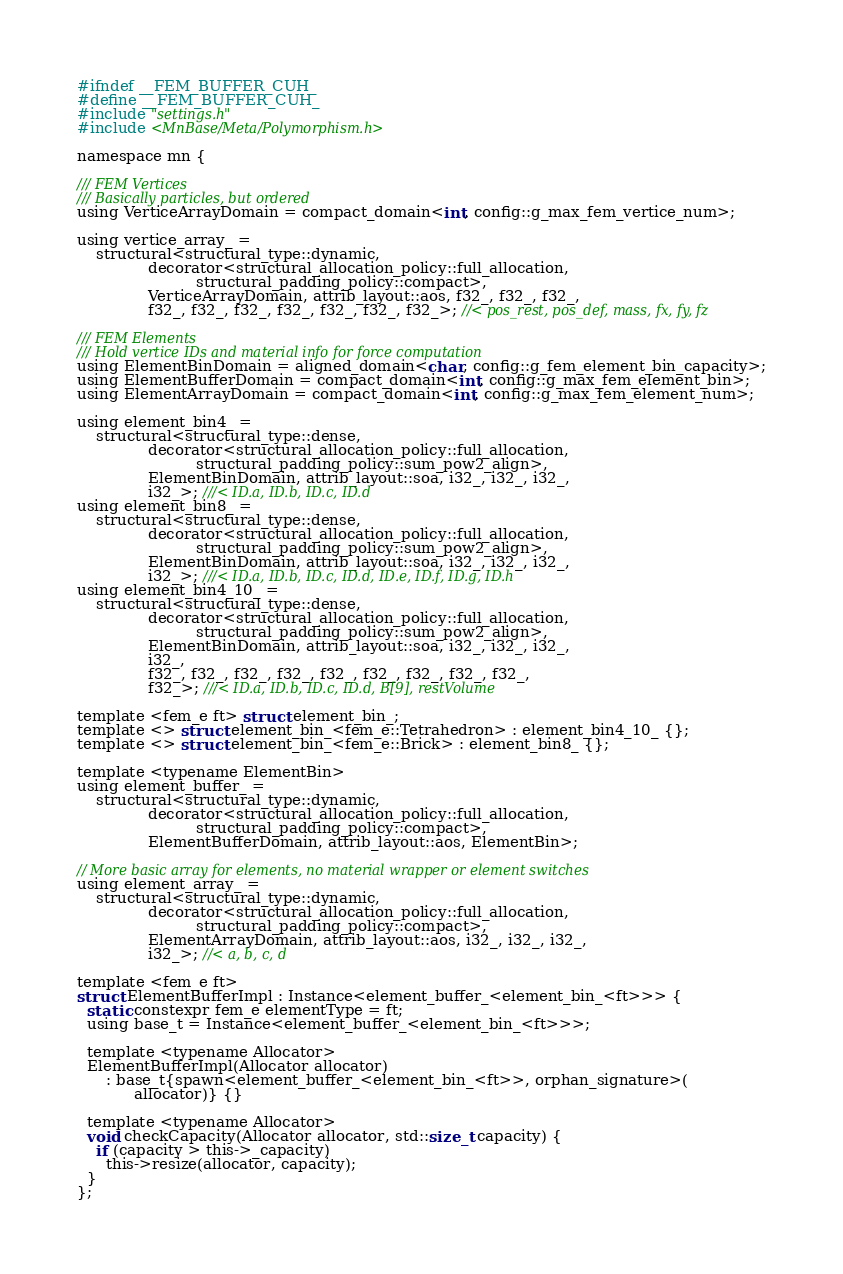<code> <loc_0><loc_0><loc_500><loc_500><_Cuda_>#ifndef __FEM_BUFFER_CUH_
#define __FEM_BUFFER_CUH_
#include "settings.h"
#include <MnBase/Meta/Polymorphism.h>

namespace mn {

/// FEM Vertices
/// Basically particles, but ordered
using VerticeArrayDomain = compact_domain<int, config::g_max_fem_vertice_num>;

using vertice_array_ =
    structural<structural_type::dynamic,
               decorator<structural_allocation_policy::full_allocation,
                         structural_padding_policy::compact>,
               VerticeArrayDomain, attrib_layout::aos, f32_, f32_, f32_,
               f32_, f32_, f32_, f32_, f32_, f32_, f32_>; //< pos_rest, pos_def, mass, fx, fy, fz

/// FEM Elements
/// Hold vertice IDs and material info for force computation
using ElementBinDomain = aligned_domain<char, config::g_fem_element_bin_capacity>;
using ElementBufferDomain = compact_domain<int, config::g_max_fem_element_bin>;
using ElementArrayDomain = compact_domain<int, config::g_max_fem_element_num>;

using element_bin4_ =
    structural<structural_type::dense,
               decorator<structural_allocation_policy::full_allocation,
                         structural_padding_policy::sum_pow2_align>,
               ElementBinDomain, attrib_layout::soa, i32_, i32_, i32_,
               i32_>; ///< ID.a, ID.b, ID.c, ID.d
using element_bin8_ =
    structural<structural_type::dense,
               decorator<structural_allocation_policy::full_allocation,
                         structural_padding_policy::sum_pow2_align>,
               ElementBinDomain, attrib_layout::soa, i32_, i32_, i32_,
               i32_>; ///< ID.a, ID.b, ID.c, ID.d, ID.e, ID.f, ID.g, ID.h
using element_bin4_10_ =
    structural<structural_type::dense,
               decorator<structural_allocation_policy::full_allocation,
                         structural_padding_policy::sum_pow2_align>,
               ElementBinDomain, attrib_layout::soa, i32_, i32_, i32_,
               i32_, 
               f32_, f32_, f32_, f32_, f32_, f32_, f32_, f32_, f32_, 
               f32_>; ///< ID.a, ID.b, ID.c, ID.d, B[9], restVolume

template <fem_e ft> struct element_bin_;
template <> struct element_bin_<fem_e::Tetrahedron> : element_bin4_10_ {};
template <> struct element_bin_<fem_e::Brick> : element_bin8_ {};

template <typename ElementBin>
using element_buffer_ =
    structural<structural_type::dynamic,
               decorator<structural_allocation_policy::full_allocation,
                         structural_padding_policy::compact>,
               ElementBufferDomain, attrib_layout::aos, ElementBin>;

// More basic array for elements, no material wrapper or element switches
using element_array_ =
    structural<structural_type::dynamic,
               decorator<structural_allocation_policy::full_allocation,
                         structural_padding_policy::compact>,
               ElementArrayDomain, attrib_layout::aos, i32_, i32_, i32_,
               i32_>; //< a, b, c, d

template <fem_e ft>
struct ElementBufferImpl : Instance<element_buffer_<element_bin_<ft>>> {
  static constexpr fem_e elementType = ft;
  using base_t = Instance<element_buffer_<element_bin_<ft>>>;

  template <typename Allocator>
  ElementBufferImpl(Allocator allocator)
      : base_t{spawn<element_buffer_<element_bin_<ft>>, orphan_signature>(
            allocator)} {}

  template <typename Allocator>
  void checkCapacity(Allocator allocator, std::size_t capacity) {
    if (capacity > this->_capacity)
      this->resize(allocator, capacity);
  }
};

</code> 